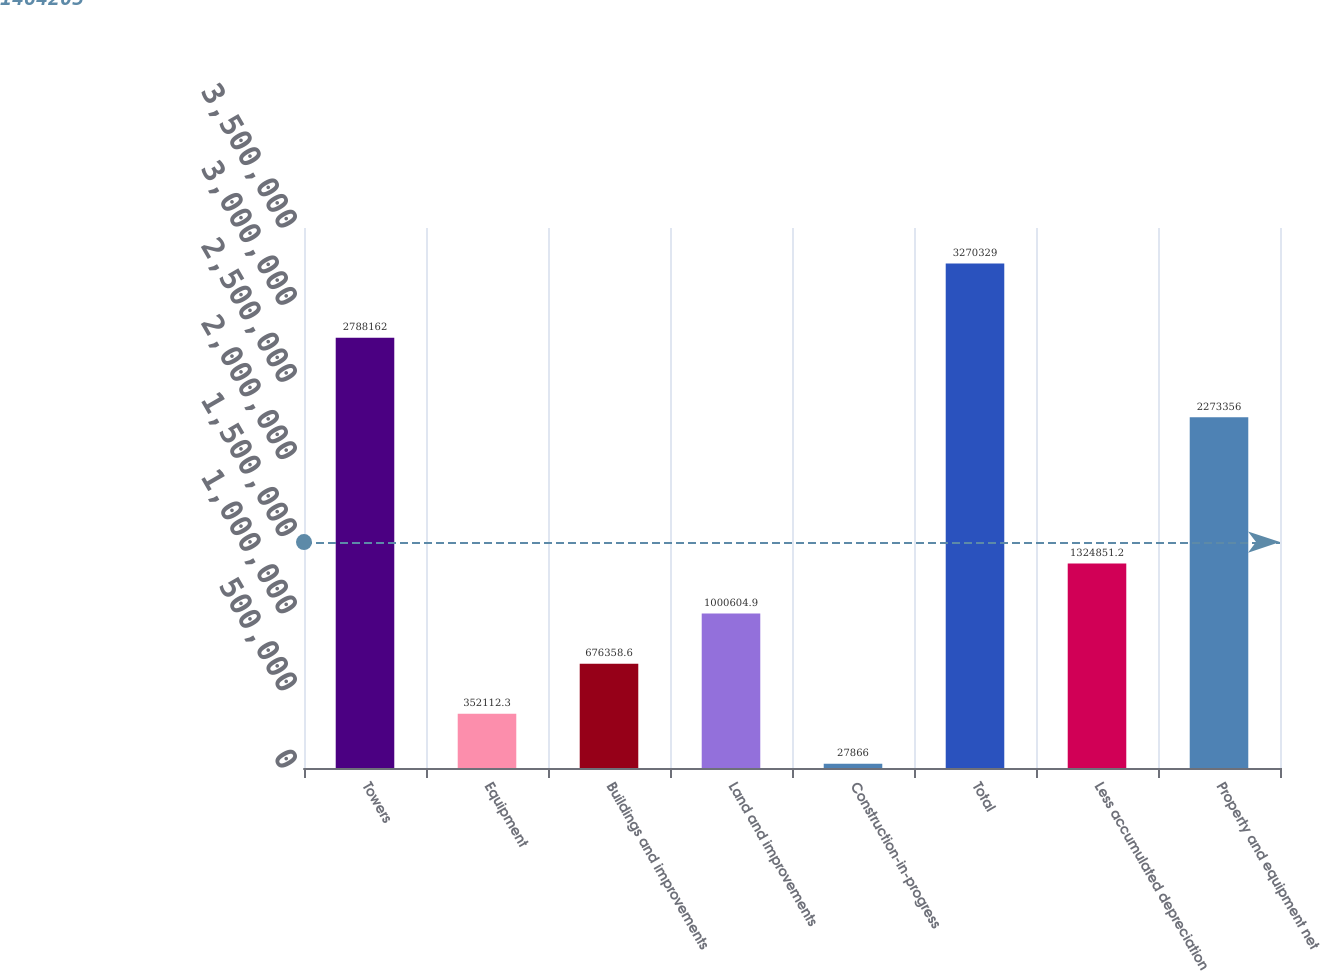Convert chart to OTSL. <chart><loc_0><loc_0><loc_500><loc_500><bar_chart><fcel>Towers<fcel>Equipment<fcel>Buildings and improvements<fcel>Land and improvements<fcel>Construction-in-progress<fcel>Total<fcel>Less accumulated depreciation<fcel>Property and equipment net<nl><fcel>2.78816e+06<fcel>352112<fcel>676359<fcel>1.0006e+06<fcel>27866<fcel>3.27033e+06<fcel>1.32485e+06<fcel>2.27336e+06<nl></chart> 